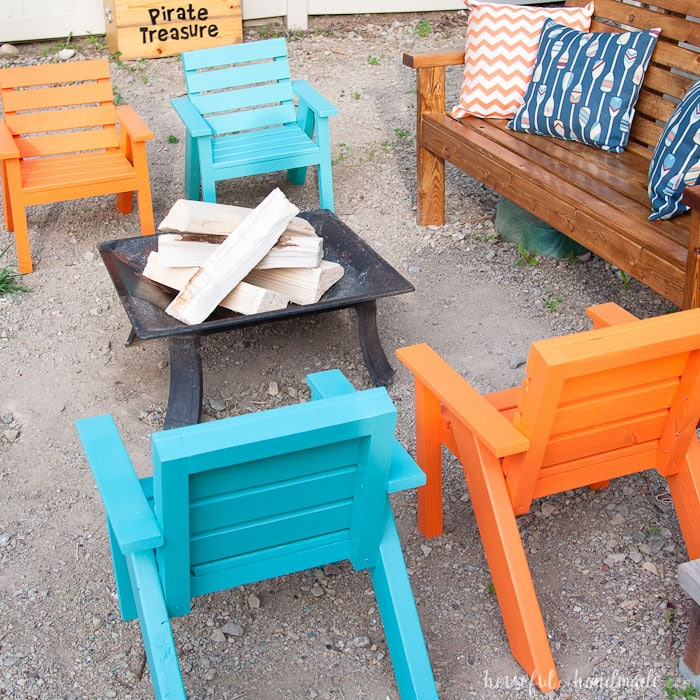Imagine this area at night; what sensory experiences might guests encounter? At night, guests would be delighted by the crackling sounds of the fire pit, the warmth emanating from the flames, and the glow of the fire casting shadows around the area. The smell of burning wood would add an earthy, homey scent to the air. If there are additional light sources like fairy lights, they would provide a soft, twinkling illumination. The cool night air would be in contrast to the warmth of the fire, creating a cozy atmosphere. Occasional laughter and conversation would punctuate the calm of the evening, enhancing the overall sensory experience. Create an elaborate backstory for how this pirate-themed backyard setup came to be. Years ago, an adventurous family traveled across the Caribbean, exploring remote islands and collecting stories of hidden treasures and pirate legends. One summer, they decided to bring those tales to life in their own backyard. They constructed a fire pit reminiscent of beach campfires where pirates once told tales of the sea. The Adirondack chairs were painted in vibrant colors, representing the lively nature of island life. The 'Pirate Treasure' sign was hand-painted as a homage to the maps and clues they had collected. The family began hosting annual 'pirate gatherings,' complete with treasure hunts, storytelling, and themed games, creating magical memories for themselves and their guests. This setup is a testament to their love for adventure and imaginative play, and each item in the backyard serves as a piece of their enchanting journey. 